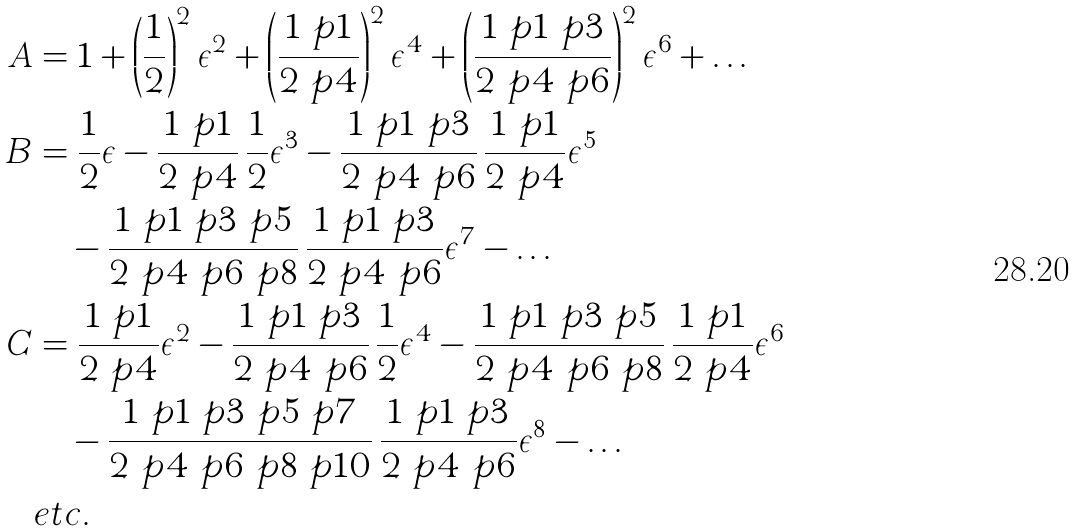<formula> <loc_0><loc_0><loc_500><loc_500>A & = 1 + \left ( \frac { 1 } { 2 } \right ) ^ { 2 } \epsilon ^ { 2 } + \left ( \frac { 1 \ p 1 } { 2 \ p 4 } \right ) ^ { 2 } \epsilon ^ { 4 } + \left ( \frac { 1 \ p 1 \ p 3 } { 2 \ p 4 \ p 6 } \right ) ^ { 2 } \epsilon ^ { 6 } + \dots \\ B & = \frac { 1 } { 2 } \epsilon - \frac { 1 \ p 1 } { 2 \ p 4 } \, \frac { 1 } { 2 } \epsilon ^ { 3 } - \frac { 1 \ p 1 \ p 3 } { 2 \ p 4 \ p 6 } \, \frac { 1 \ p 1 } { 2 \ p 4 } \epsilon ^ { 5 } \\ & \quad - \frac { 1 \ p 1 \ p 3 \ p 5 } { 2 \ p 4 \ p 6 \ p 8 } \, \frac { 1 \ p 1 \ p 3 } { 2 \ p 4 \ p 6 } \epsilon ^ { 7 } - \dots \\ C & = \frac { 1 \ p 1 } { 2 \ p 4 } \epsilon ^ { 2 } - \frac { 1 \ p 1 \ p 3 } { 2 \ p 4 \ p 6 } \, \frac { 1 } { 2 } \epsilon ^ { 4 } - \frac { 1 \ p 1 \ p 3 \ p 5 } { 2 \ p 4 \ p 6 \ p 8 } \, \frac { 1 \ p 1 } { 2 \ p 4 } \epsilon ^ { 6 } \\ & \quad - \frac { 1 \ p 1 \ p 3 \ p 5 \ p 7 } { 2 \ p 4 \ p 6 \ p 8 \ p 1 0 } \, \frac { 1 \ p 1 \ p 3 } { 2 \ p 4 \ p 6 } \epsilon ^ { 8 } - \dots \\ & e t c .</formula> 